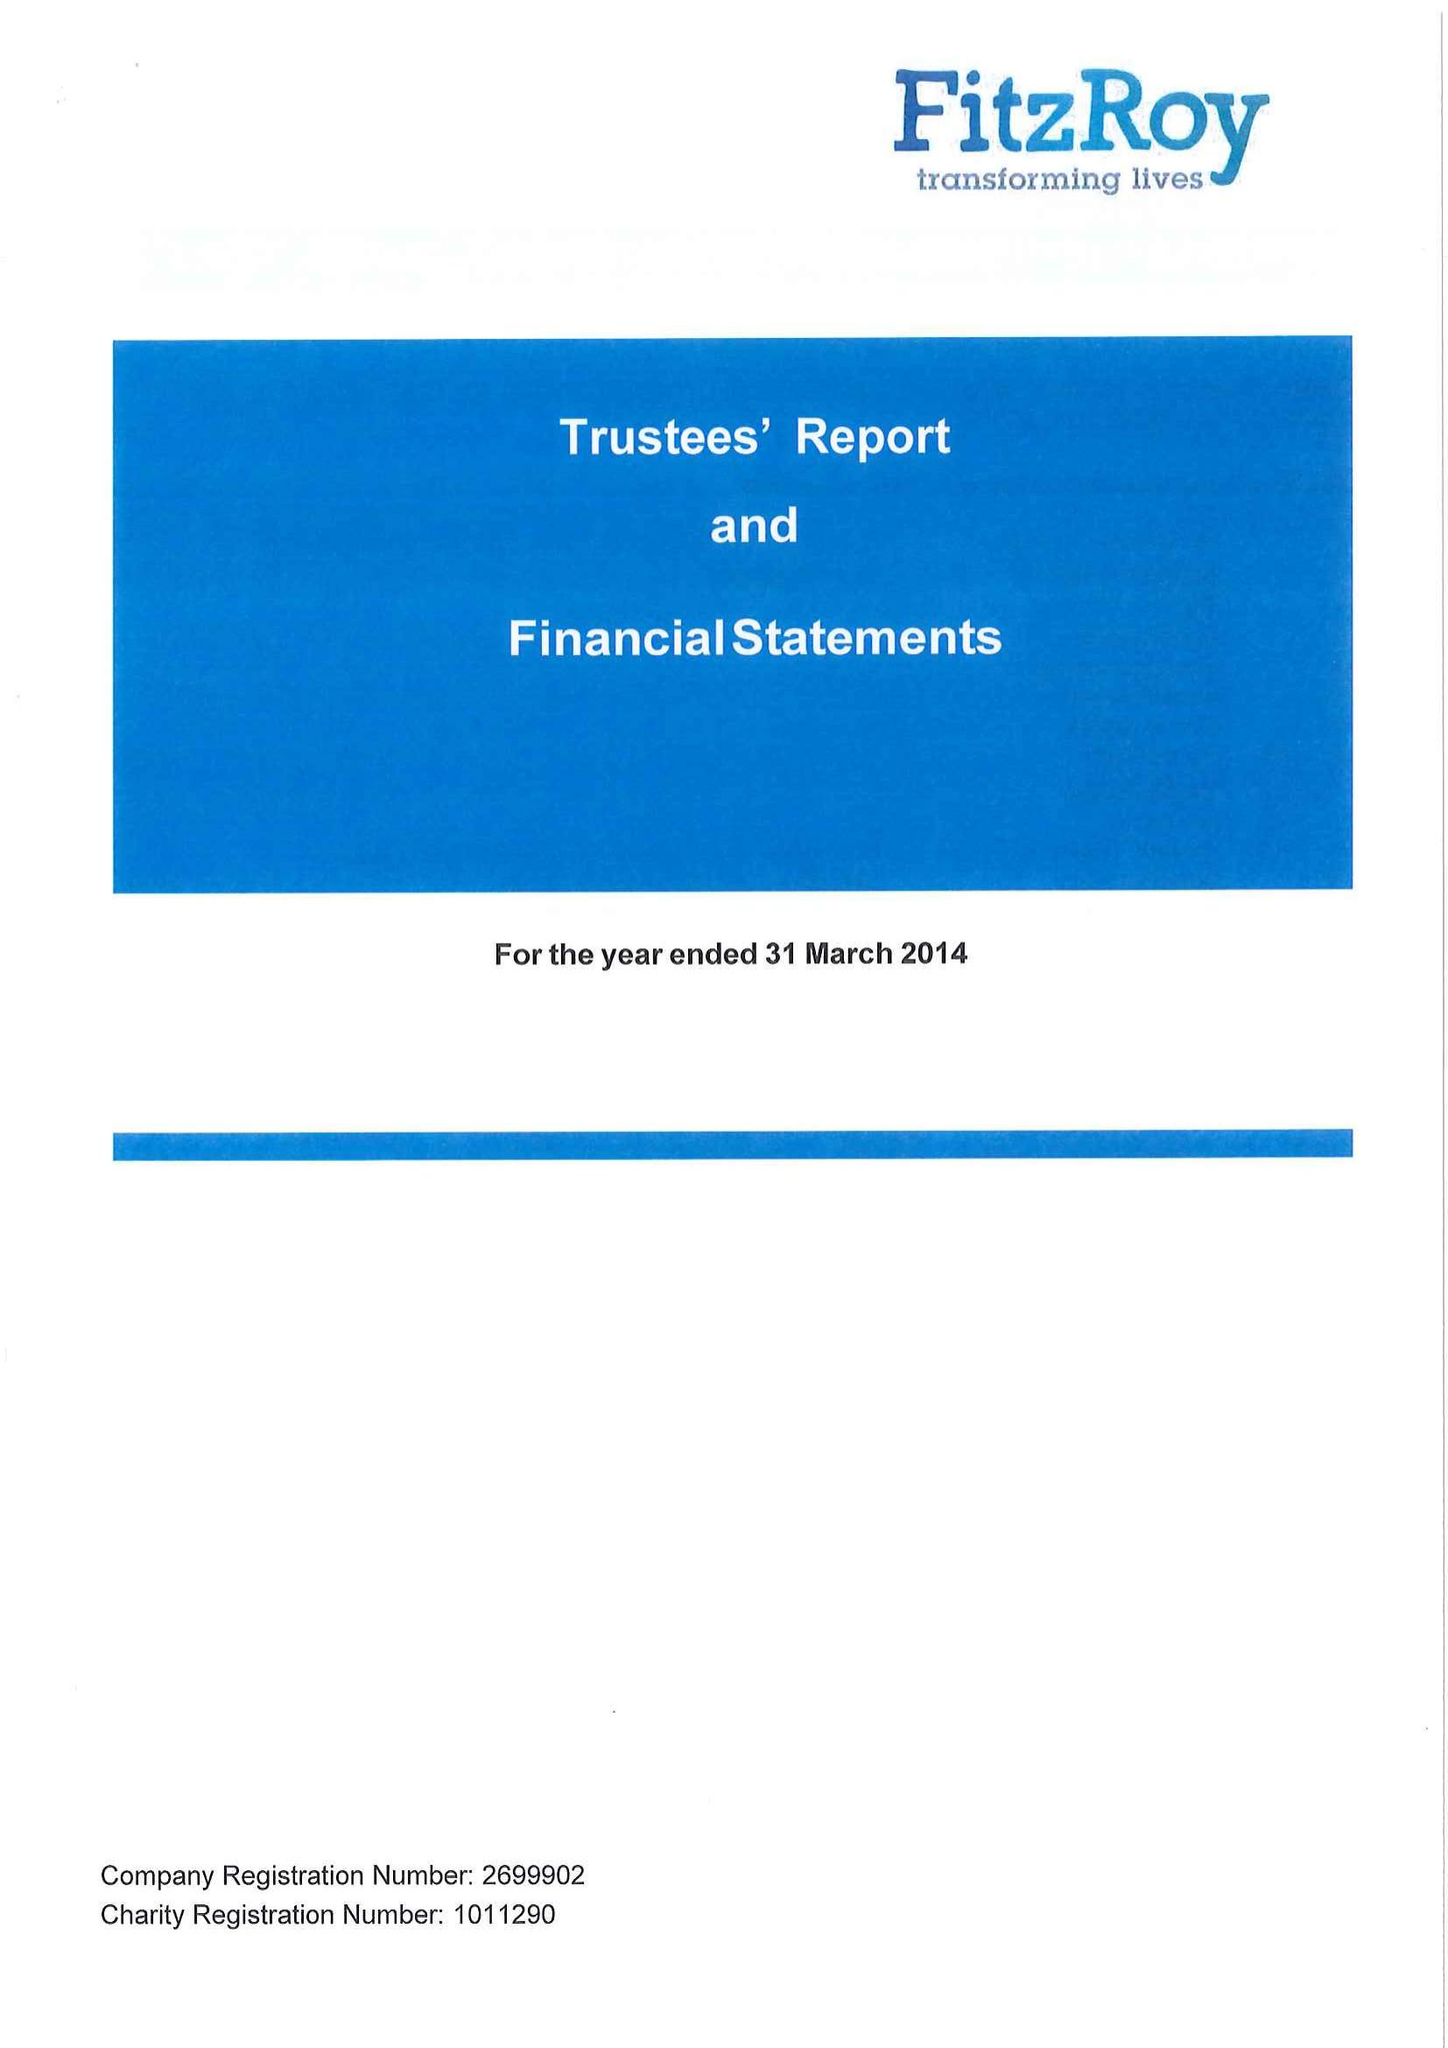What is the value for the address__post_town?
Answer the question using a single word or phrase. PETERSFIELD 